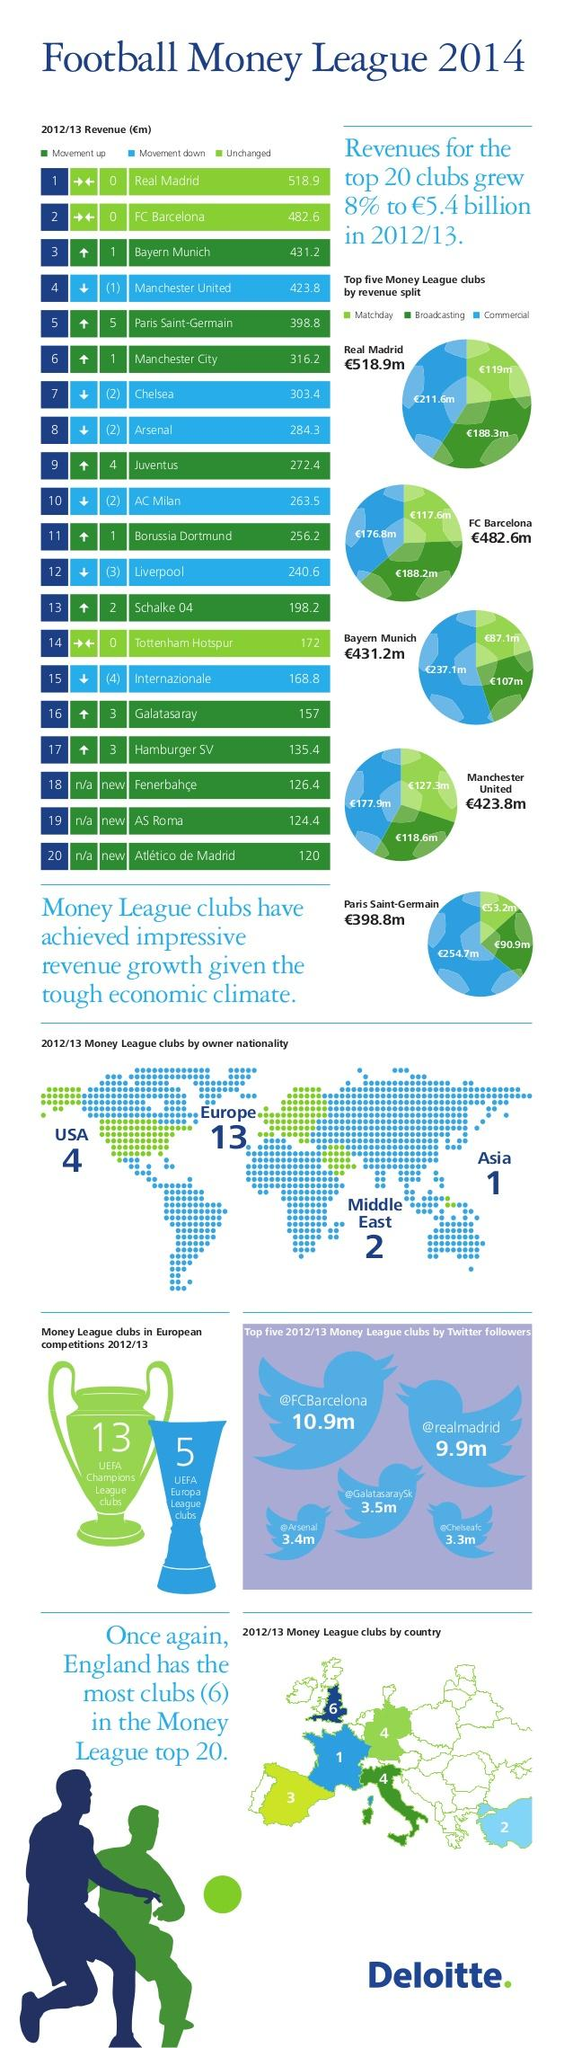Identify some key points in this picture. The up arrow indicates a movement upward. Of the three league clubs with revenue ranging from €300 million to €400 million, Chelsea, Manchester City, and Paris Saint-Germain are among the highest earners in the industry. There are currently 5 UEFA Europa League clubs. In Europe, England has the highest number of clubs in the Money League Top 20. Four Money League clubs are currently owned by the United States of America. 